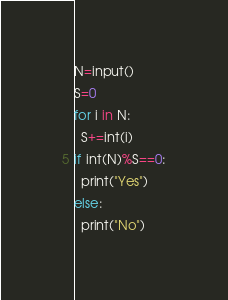<code> <loc_0><loc_0><loc_500><loc_500><_Python_>N=input()
S=0
for i in N:
  S+=int(i)
if int(N)%S==0:
  print("Yes")
else:
  print("No")</code> 